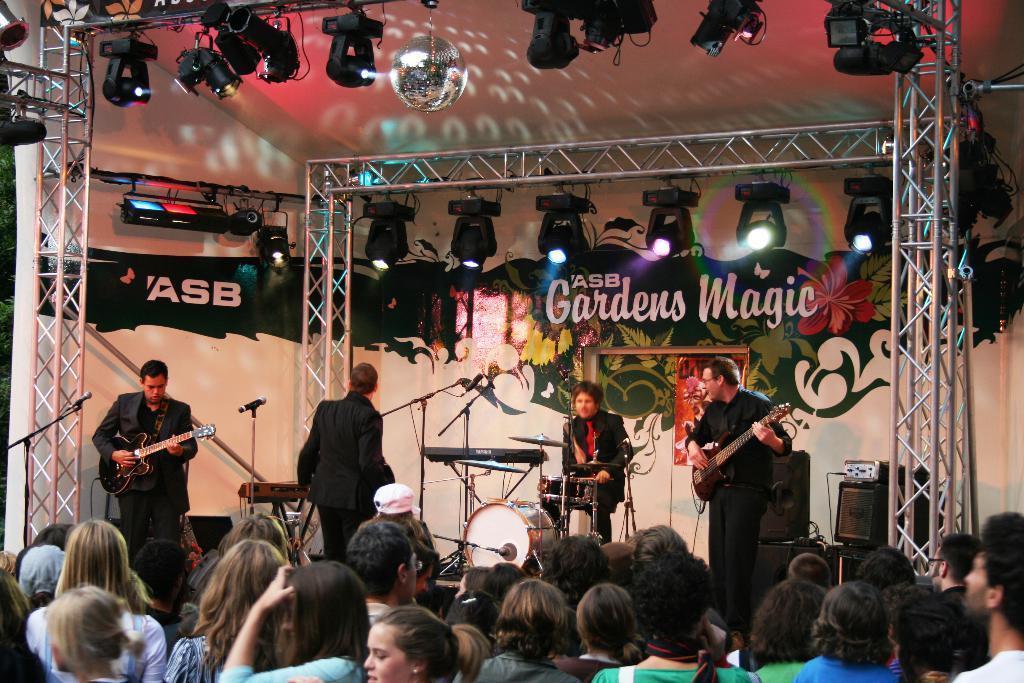How would you summarize this image in a sentence or two? In the image there are three people standing. On left side there is a man holding a guitar and playing it in front of a microphone and right side there is another man holding guitar and playing it. In middle there is a person sitting on chair and playing a musical instrument and there are group of people as audience in background there are hoardings on top there is a roof with few lights. 